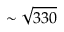Convert formula to latex. <formula><loc_0><loc_0><loc_500><loc_500>\sim \sqrt { 3 3 0 }</formula> 